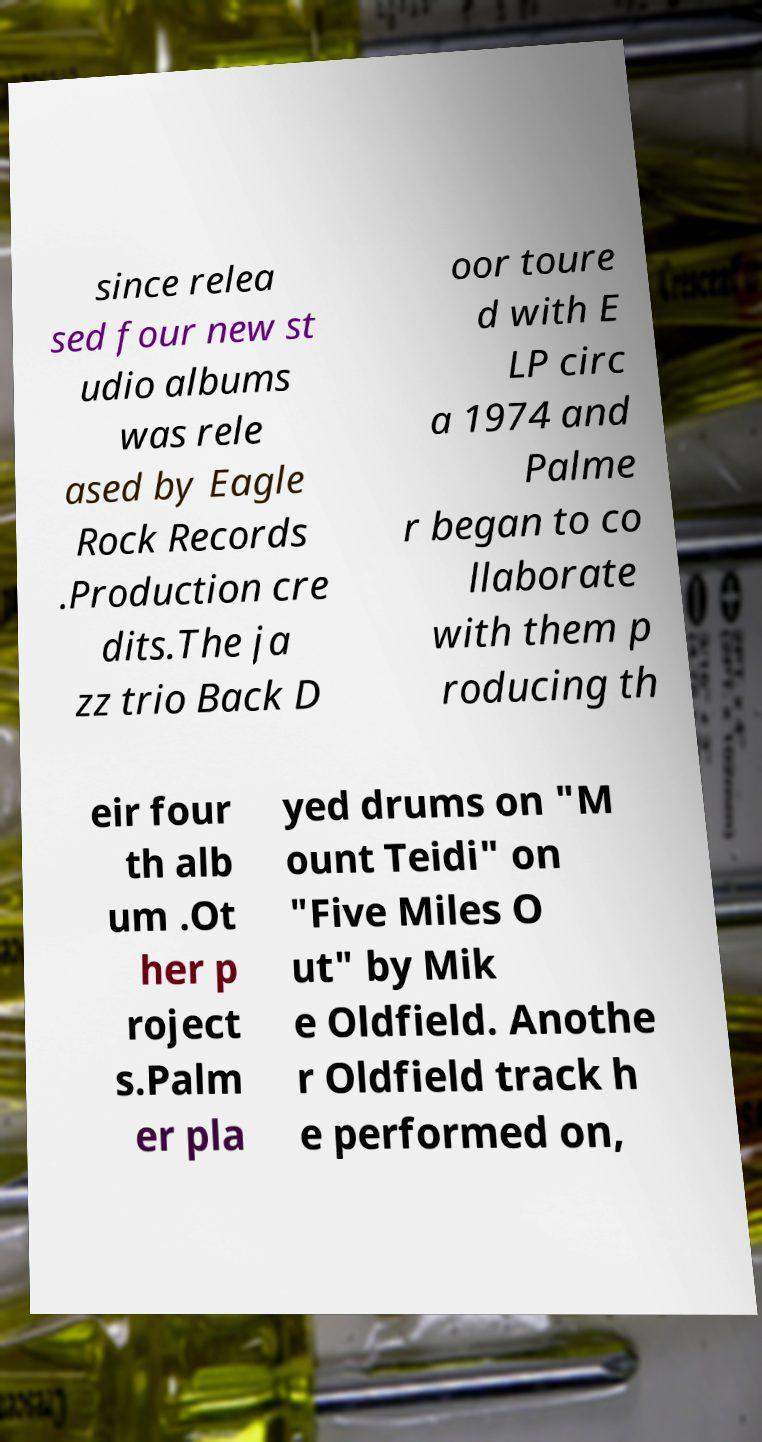Please read and relay the text visible in this image. What does it say? since relea sed four new st udio albums was rele ased by Eagle Rock Records .Production cre dits.The ja zz trio Back D oor toure d with E LP circ a 1974 and Palme r began to co llaborate with them p roducing th eir four th alb um .Ot her p roject s.Palm er pla yed drums on "M ount Teidi" on "Five Miles O ut" by Mik e Oldfield. Anothe r Oldfield track h e performed on, 